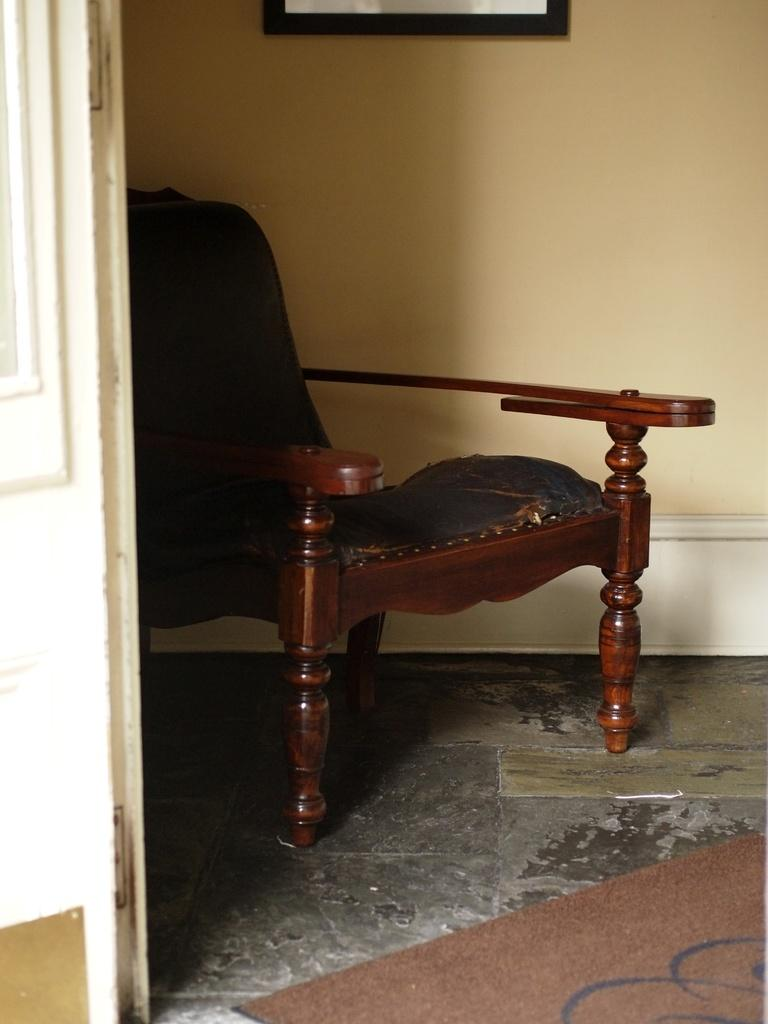What type of furniture is in the image? There is a chair in the image. What is on the chair? The chair has a cushion on it. What can be seen on the left side of the image? There is a door on the left side of the image. What is visible in the background of the image? There is a wall visible in the background of the image. What type of vest is hanging on the wall in the image? There is no vest present in the image; only a chair, a cushion, a door, and a wall are visible. 